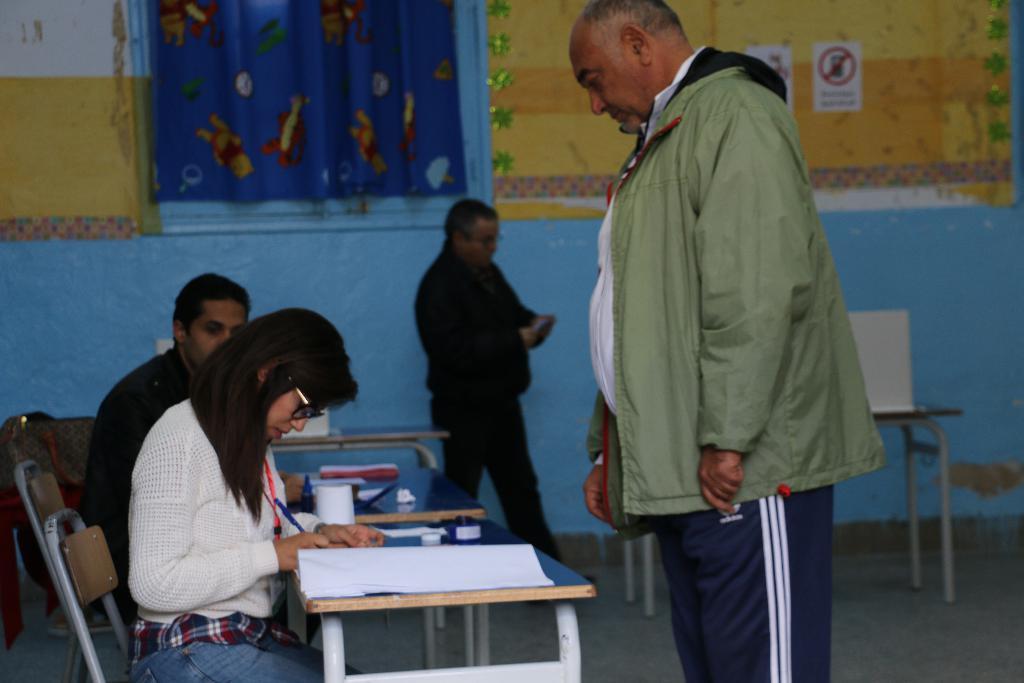In one or two sentences, can you explain what this image depicts? Here we can see a man and a woman sitting on chairs in front of a table and on the table we can see a book. We can see this woman is holding a pen in her hand and writing. This is a floor. We can see one man standing in front of a table. We can see other man standing near to the wall. This is a curtain. We can see poster over a wall. 